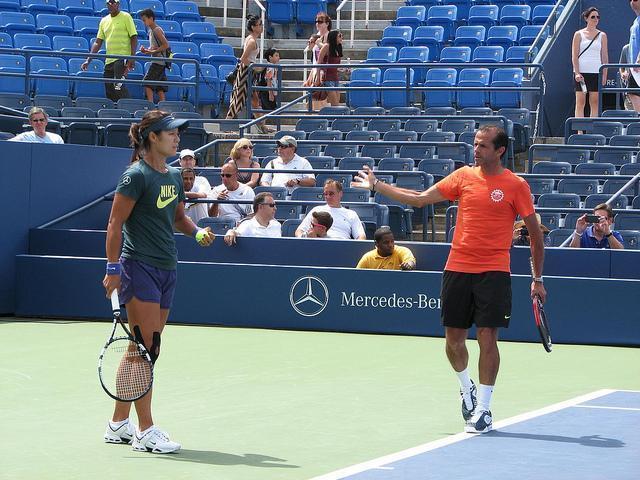How many people are there?
Give a very brief answer. 4. 